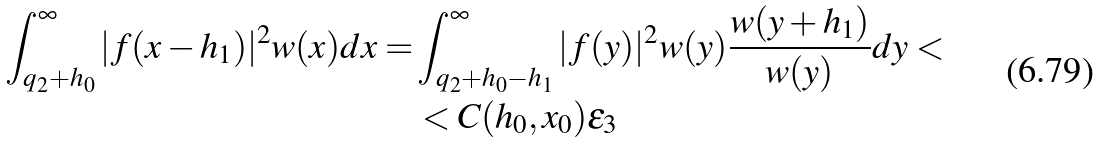Convert formula to latex. <formula><loc_0><loc_0><loc_500><loc_500>\int _ { q _ { 2 } + h _ { 0 } } ^ { \infty } | f ( x - h _ { 1 } ) | ^ { 2 } w ( x ) d x = & \int _ { q _ { 2 } + h _ { 0 } - h _ { 1 } } ^ { \infty } | f ( y ) | ^ { 2 } w ( y ) \frac { w ( y + h _ { 1 } ) } { w ( y ) } d y < \\ & < C ( h _ { 0 } , x _ { 0 } ) \epsilon _ { 3 }</formula> 